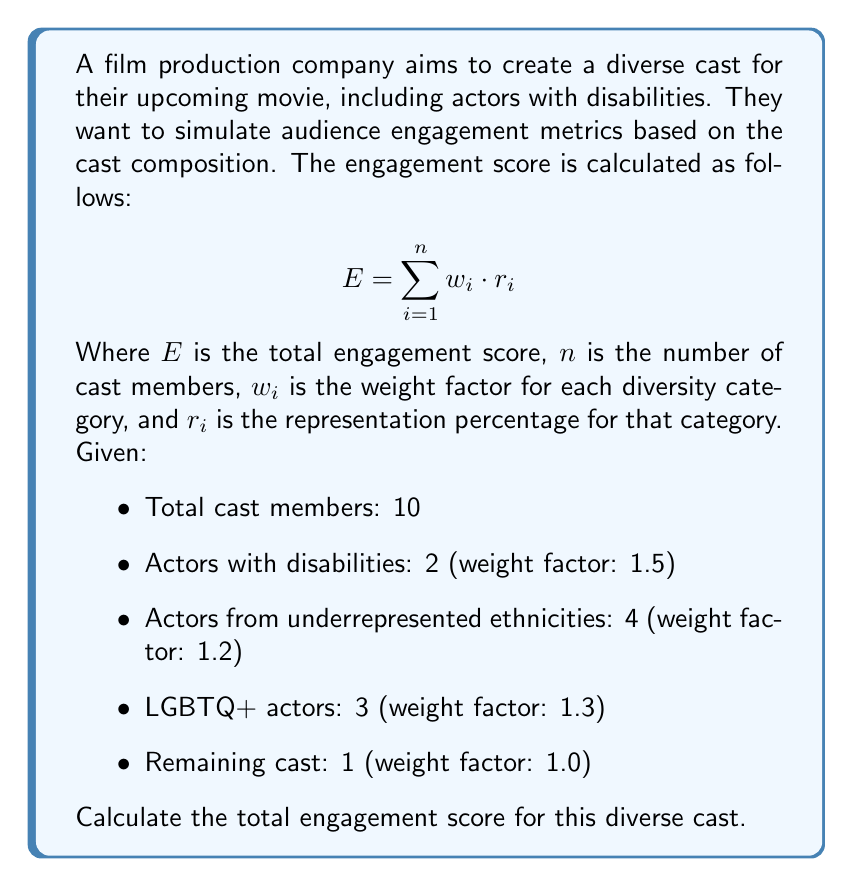Help me with this question. To solve this problem, we'll follow these steps:

1. Calculate the representation percentage ($r_i$) for each category:
   - Actors with disabilities: $r_1 = \frac{2}{10} = 0.2$ or 20%
   - Actors from underrepresented ethnicities: $r_2 = \frac{4}{10} = 0.4$ or 40%
   - LGBTQ+ actors: $r_3 = \frac{3}{10} = 0.3$ or 30%
   - Remaining cast: $r_4 = \frac{1}{10} = 0.1$ or 10%

2. Multiply each representation percentage by its corresponding weight factor:
   - Actors with disabilities: $1.5 \cdot 0.2 = 0.3$
   - Actors from underrepresented ethnicities: $1.2 \cdot 0.4 = 0.48$
   - LGBTQ+ actors: $1.3 \cdot 0.3 = 0.39$
   - Remaining cast: $1.0 \cdot 0.1 = 0.1$

3. Sum up all the weighted values to get the total engagement score:

   $E = \sum_{i=1}^{n} w_i \cdot r_i$
   $E = (1.5 \cdot 0.2) + (1.2 \cdot 0.4) + (1.3 \cdot 0.3) + (1.0 \cdot 0.1)$
   $E = 0.3 + 0.48 + 0.39 + 0.1$
   $E = 1.27$

Therefore, the total engagement score for this diverse cast is 1.27.
Answer: 1.27 